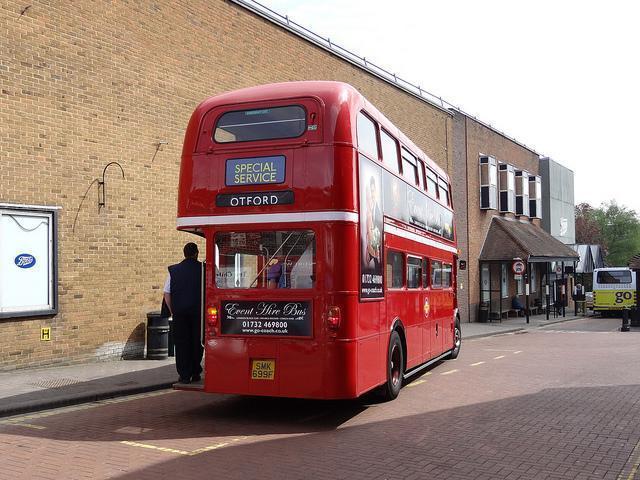What word is written before service?
Indicate the correct response and explain using: 'Answer: answer
Rationale: rationale.'
Options: Out of, special, secret, in. Answer: special.
Rationale: The sign on the front of the bus says "special service" in yellow. 